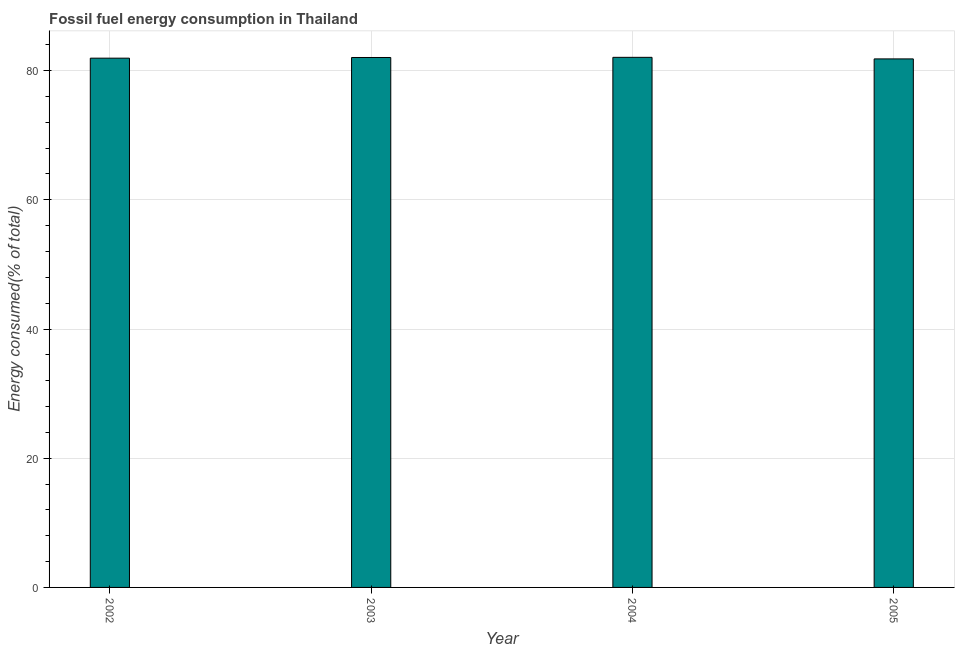Does the graph contain grids?
Provide a succinct answer. Yes. What is the title of the graph?
Provide a short and direct response. Fossil fuel energy consumption in Thailand. What is the label or title of the Y-axis?
Provide a short and direct response. Energy consumed(% of total). What is the fossil fuel energy consumption in 2004?
Offer a terse response. 82.06. Across all years, what is the maximum fossil fuel energy consumption?
Ensure brevity in your answer.  82.06. Across all years, what is the minimum fossil fuel energy consumption?
Your answer should be very brief. 81.81. In which year was the fossil fuel energy consumption maximum?
Offer a terse response. 2004. In which year was the fossil fuel energy consumption minimum?
Provide a succinct answer. 2005. What is the sum of the fossil fuel energy consumption?
Your answer should be very brief. 327.83. What is the difference between the fossil fuel energy consumption in 2003 and 2004?
Your response must be concise. -0.03. What is the average fossil fuel energy consumption per year?
Keep it short and to the point. 81.96. What is the median fossil fuel energy consumption?
Make the answer very short. 81.98. Do a majority of the years between 2003 and 2005 (inclusive) have fossil fuel energy consumption greater than 20 %?
Your answer should be very brief. Yes. What is the ratio of the fossil fuel energy consumption in 2002 to that in 2003?
Offer a terse response. 1. Is the difference between the fossil fuel energy consumption in 2003 and 2005 greater than the difference between any two years?
Your answer should be very brief. No. What is the difference between the highest and the second highest fossil fuel energy consumption?
Give a very brief answer. 0.03. What is the difference between the highest and the lowest fossil fuel energy consumption?
Ensure brevity in your answer.  0.24. What is the Energy consumed(% of total) of 2002?
Ensure brevity in your answer.  81.93. What is the Energy consumed(% of total) in 2003?
Your answer should be compact. 82.03. What is the Energy consumed(% of total) of 2004?
Provide a short and direct response. 82.06. What is the Energy consumed(% of total) in 2005?
Keep it short and to the point. 81.81. What is the difference between the Energy consumed(% of total) in 2002 and 2003?
Keep it short and to the point. -0.1. What is the difference between the Energy consumed(% of total) in 2002 and 2004?
Keep it short and to the point. -0.13. What is the difference between the Energy consumed(% of total) in 2002 and 2005?
Make the answer very short. 0.12. What is the difference between the Energy consumed(% of total) in 2003 and 2004?
Ensure brevity in your answer.  -0.03. What is the difference between the Energy consumed(% of total) in 2003 and 2005?
Offer a terse response. 0.22. What is the difference between the Energy consumed(% of total) in 2004 and 2005?
Provide a succinct answer. 0.24. What is the ratio of the Energy consumed(% of total) in 2002 to that in 2003?
Ensure brevity in your answer.  1. What is the ratio of the Energy consumed(% of total) in 2003 to that in 2004?
Ensure brevity in your answer.  1. What is the ratio of the Energy consumed(% of total) in 2004 to that in 2005?
Your response must be concise. 1. 